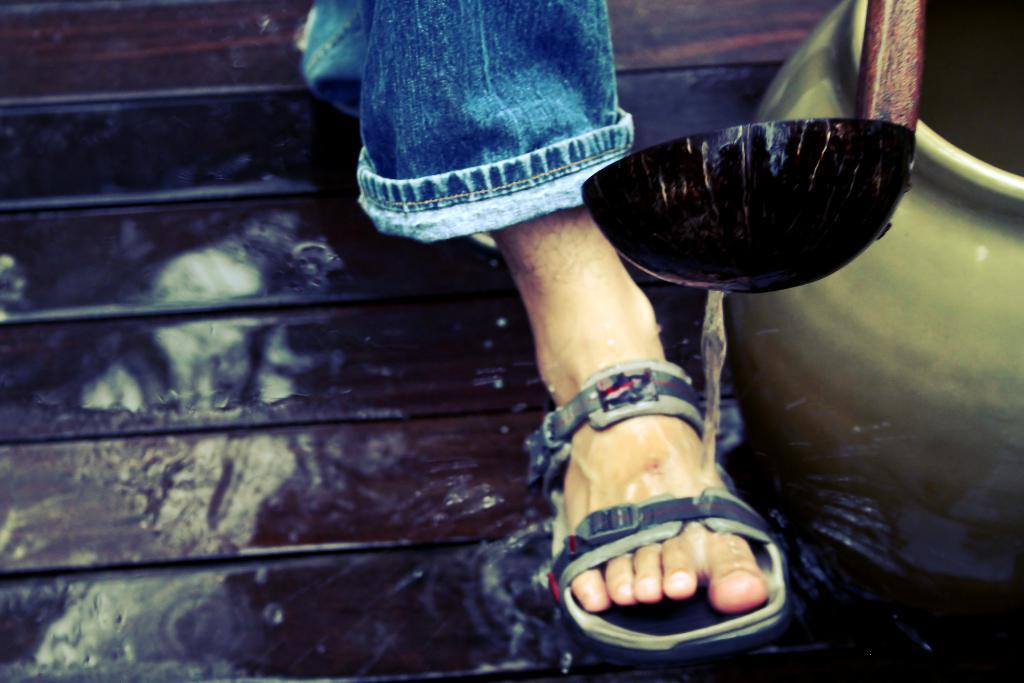What part of a person can be seen in the image? There is a leg of a person in the image. What type of clothing is the person wearing on their leg? The person is wearing blue jeans. What type of footwear is the person wearing? The person is wearing a sandal. What natural element is visible in the image? There is water visible in the image. What object can be seen in the image that might be used for cooking or storage? There is a pot in the image. What color is the black object in the image? The black object in the image is black. What type of eggs are being sold at the plantation in the image? There is no plantation or eggs present in the image. 